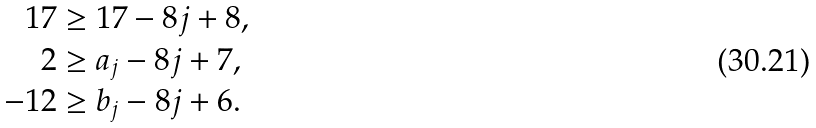Convert formula to latex. <formula><loc_0><loc_0><loc_500><loc_500>1 7 & \geq 1 7 - 8 j + 8 , \\ 2 & \geq a _ { j } - 8 j + 7 , \\ - 1 2 & \geq b _ { j } - 8 j + 6 .</formula> 